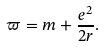Convert formula to latex. <formula><loc_0><loc_0><loc_500><loc_500>\varpi = m + \frac { e ^ { 2 } } { 2 r } .</formula> 